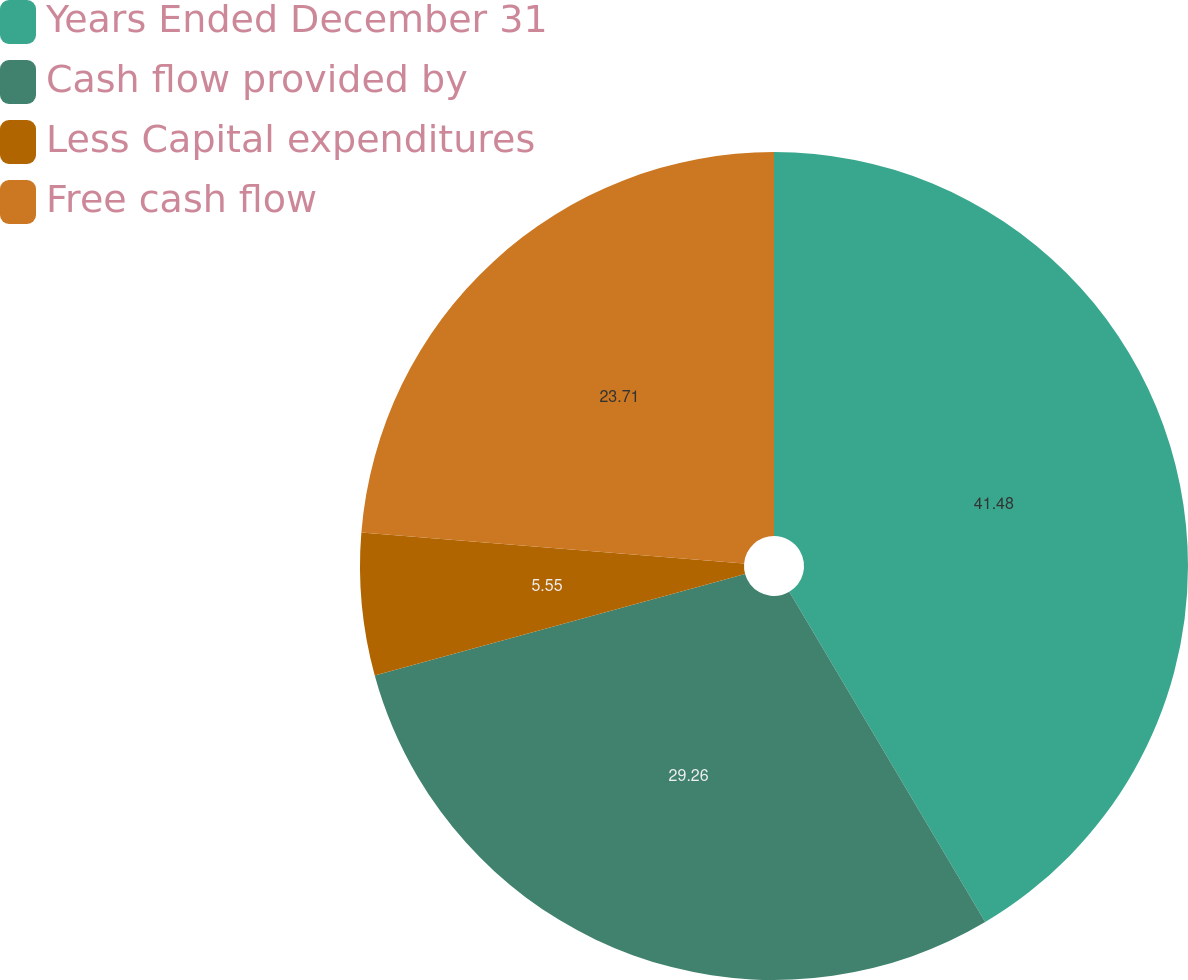Convert chart. <chart><loc_0><loc_0><loc_500><loc_500><pie_chart><fcel>Years Ended December 31<fcel>Cash flow provided by<fcel>Less Capital expenditures<fcel>Free cash flow<nl><fcel>41.48%<fcel>29.26%<fcel>5.55%<fcel>23.71%<nl></chart> 